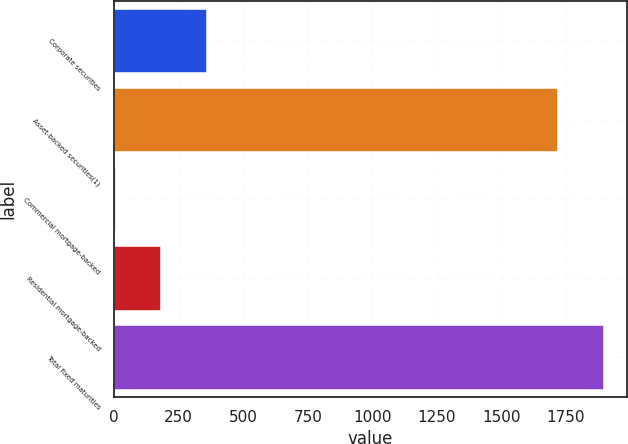Convert chart. <chart><loc_0><loc_0><loc_500><loc_500><bar_chart><fcel>Corporate securities<fcel>Asset-backed securities(1)<fcel>Commercial mortgage-backed<fcel>Residential mortgage-backed<fcel>Total fixed maturities<nl><fcel>354.6<fcel>1716<fcel>1<fcel>177.8<fcel>1892.8<nl></chart> 